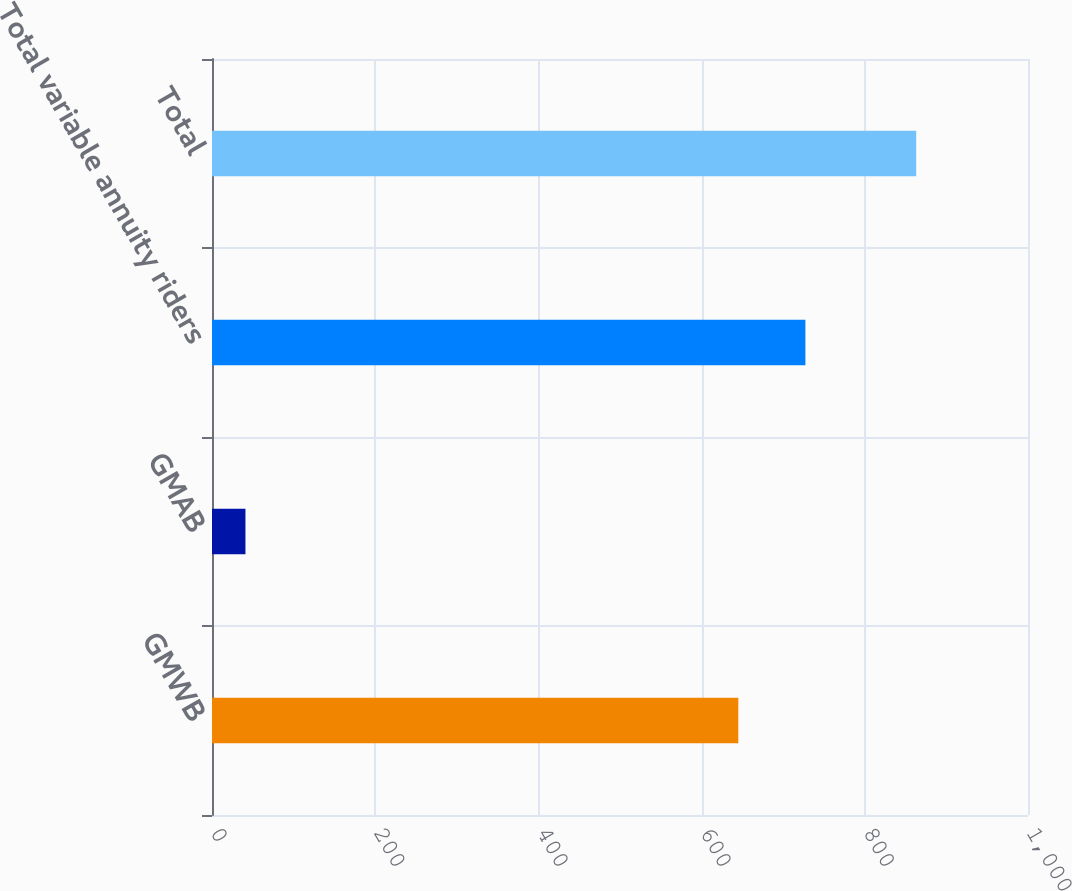Convert chart. <chart><loc_0><loc_0><loc_500><loc_500><bar_chart><fcel>GMWB<fcel>GMAB<fcel>Total variable annuity riders<fcel>Total<nl><fcel>645<fcel>41<fcel>727.2<fcel>863<nl></chart> 